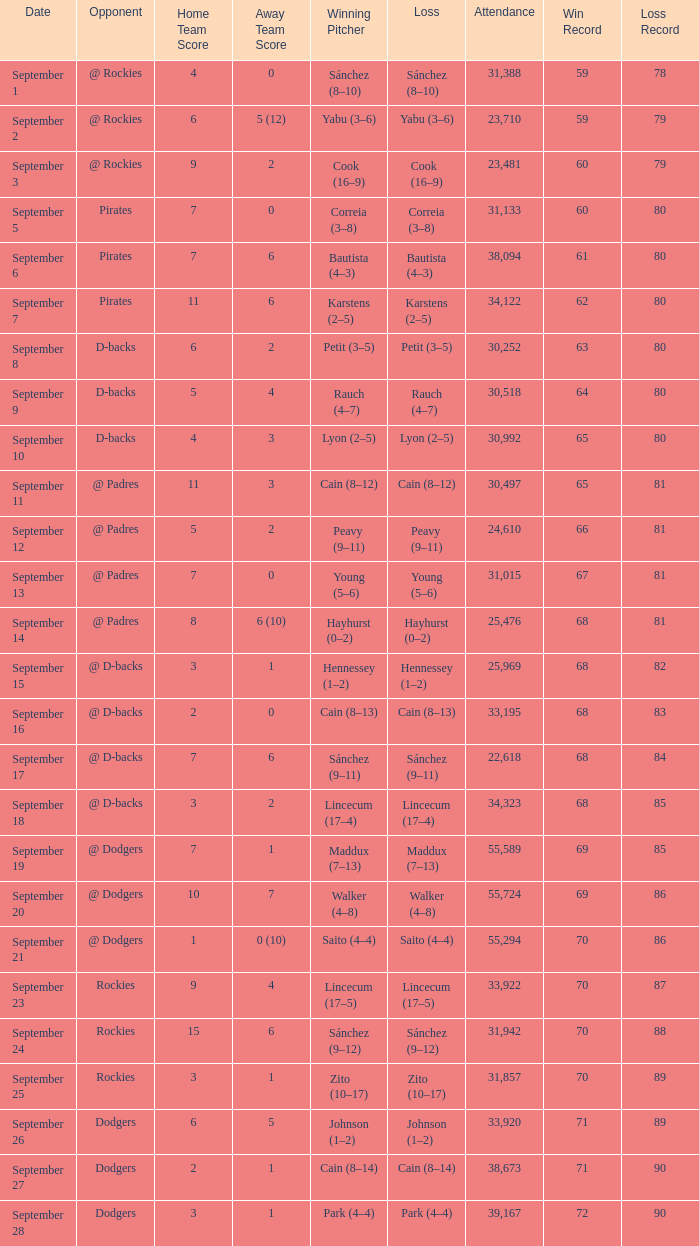What was the attendance on September 28? 39167.0. 